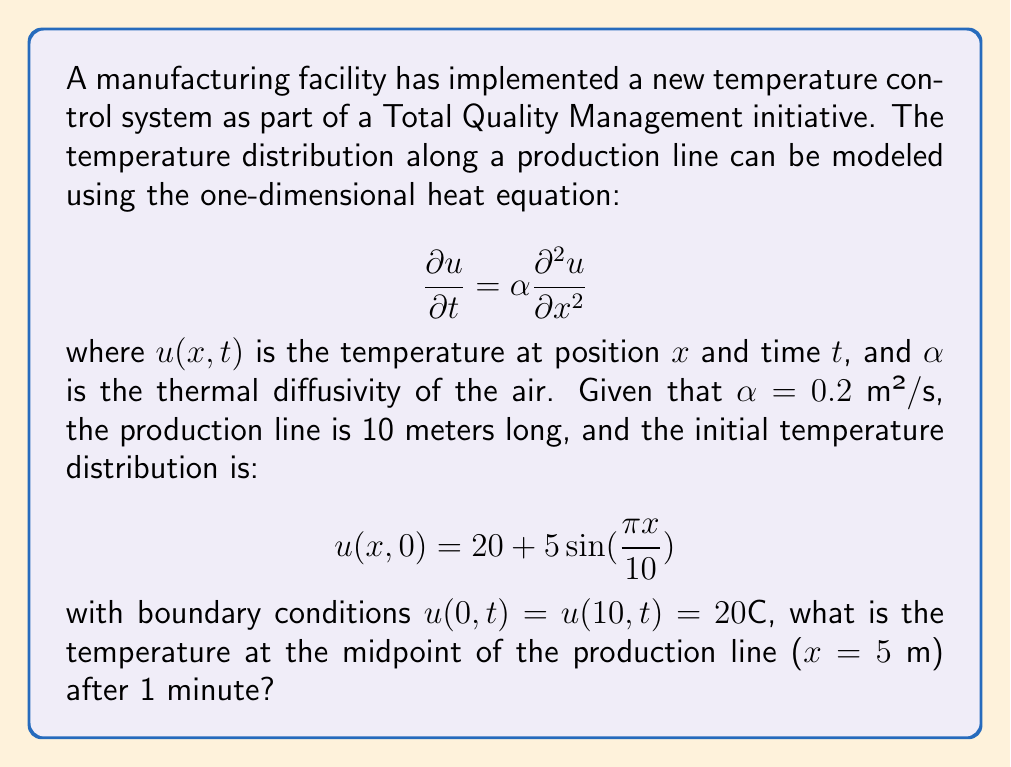Help me with this question. To solve this problem, we'll use the method of separation of variables for the heat equation.

Step 1: Separate variables
Let $u(x,t) = X(x)T(t)$. Substituting into the heat equation:

$$X(x)T'(t) = \alpha X''(x)T(t)$$
$$\frac{T'(t)}{T(t)} = \alpha \frac{X''(x)}{X(x)} = -\lambda$$

Step 2: Solve the spatial equation
$$X''(x) + \lambda X(x) = 0$$
With boundary conditions $X(0) = X(10) = 0$, we get the eigenvalues and eigenfunctions:
$$\lambda_n = (\frac{n\pi}{10})^2, \quad X_n(x) = \sin(\frac{n\pi x}{10})$$

Step 3: Solve the temporal equation
$$T'(t) + \alpha \lambda_n T(t) = 0$$
$$T_n(t) = e^{-\alpha \lambda_n t} = e^{-\alpha (\frac{n\pi}{10})^2 t}$$

Step 4: Construct the general solution
$$u(x,t) = \sum_{n=1}^{\infty} A_n \sin(\frac{n\pi x}{10}) e^{-\alpha (\frac{n\pi}{10})^2 t}$$

Step 5: Apply initial condition to find $A_n$
$$20 + 5\sin(\frac{\pi x}{10}) = \sum_{n=1}^{\infty} A_n \sin(\frac{n\pi x}{10})$$

Comparing coefficients, we see that $A_1 = 5$ and all other $A_n = 0$.

Step 6: Write the specific solution
$$u(x,t) = 20 + 5\sin(\frac{\pi x}{10}) e^{-0.2 (\frac{\pi}{10})^2 t}$$

Step 7: Calculate the temperature at $x=5$ m and $t=60$ s
$$u(5,60) = 20 + 5\sin(\frac{\pi \cdot 5}{10}) e^{-0.2 (\frac{\pi}{10})^2 \cdot 60}$$
$$u(5,60) = 20 + 5 \cdot e^{-0.2 (\frac{\pi}{10})^2 \cdot 60}$$
$$u(5,60) \approx 23.35°C$$
Answer: 23.35°C 